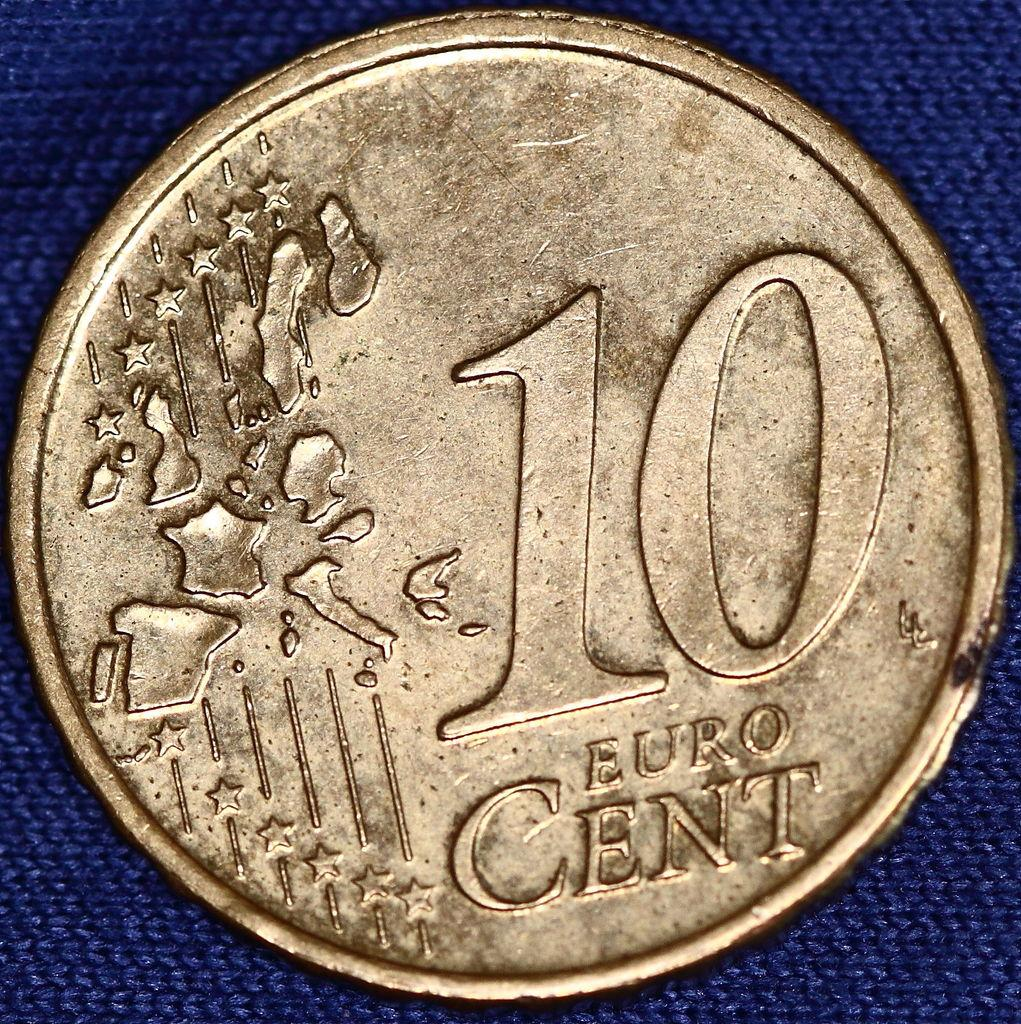<image>
Render a clear and concise summary of the photo. a coin that says '10 euro cent' on it 